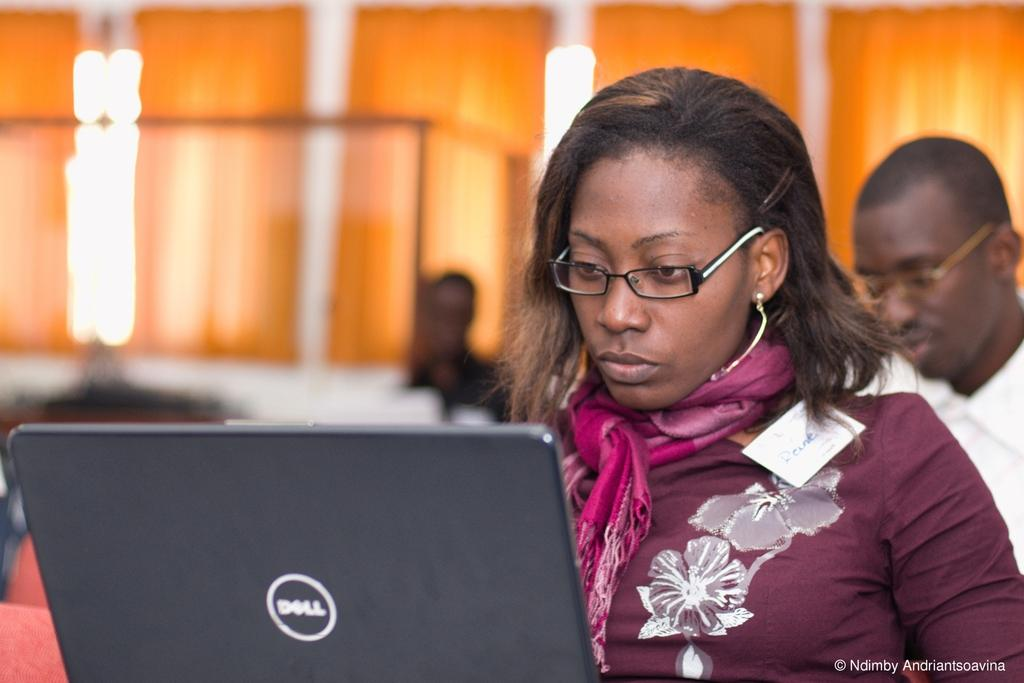Who is the main subject in the foreground of the picture? There is a woman in the foreground of the picture. What is the woman doing in the image? The woman is using a laptop. Can you describe the background of the image? The background of the image is blurred. Are there any other people visible in the image? Yes, there is a person on the right side of the image. What type of pies is the woman baking in the image? There is no indication of any pies or baking activity in the image. How does the woman interact with the laptop using her sense of touch? The image does not show the woman interacting with the laptop in any way, so it is impossible to determine how she uses her sense of touch. 